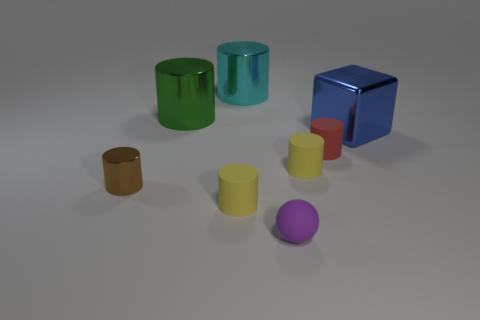Are there more yellow matte cylinders than tiny purple balls?
Offer a very short reply. Yes. What color is the big object to the left of the tiny yellow thing on the left side of the tiny yellow rubber object that is behind the tiny brown cylinder?
Provide a short and direct response. Green. Does the rubber cylinder that is on the left side of the purple rubber thing have the same color as the metal thing that is on the right side of the purple rubber sphere?
Ensure brevity in your answer.  No. How many yellow rubber things are on the left side of the yellow cylinder that is behind the small brown shiny cylinder?
Offer a very short reply. 1. Are there any large yellow balls?
Offer a very short reply. No. What number of other things are the same color as the tiny metal object?
Make the answer very short. 0. Are there fewer tiny metallic cylinders than tiny blue matte things?
Ensure brevity in your answer.  No. What is the shape of the small purple thing that is in front of the metallic cylinder that is in front of the big blue thing?
Offer a very short reply. Sphere. There is a brown cylinder; are there any matte objects behind it?
Provide a short and direct response. Yes. What color is the rubber ball that is the same size as the brown shiny cylinder?
Provide a succinct answer. Purple. 